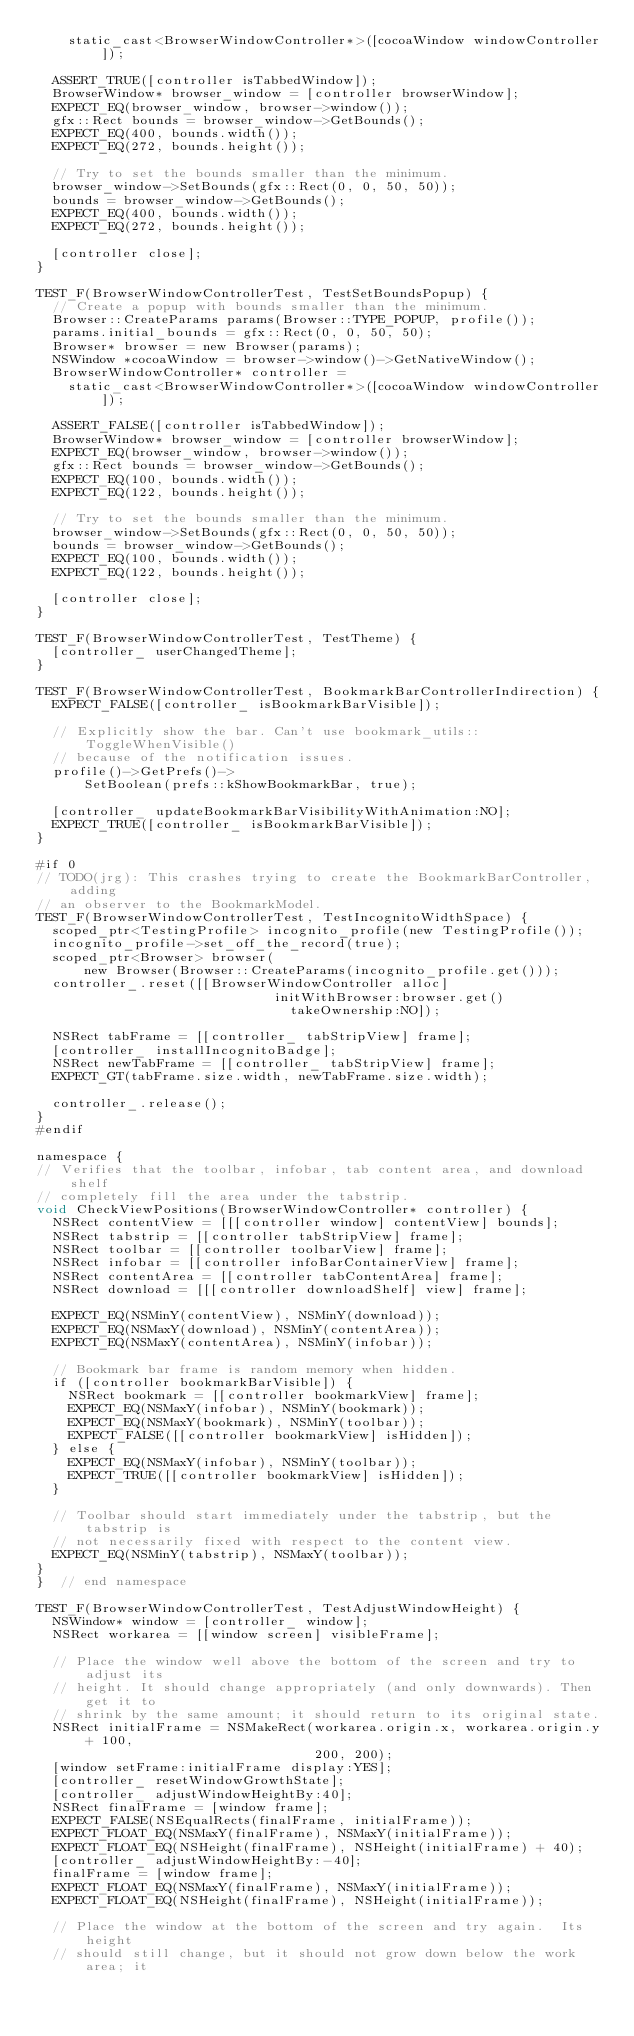Convert code to text. <code><loc_0><loc_0><loc_500><loc_500><_ObjectiveC_>    static_cast<BrowserWindowController*>([cocoaWindow windowController]);

  ASSERT_TRUE([controller isTabbedWindow]);
  BrowserWindow* browser_window = [controller browserWindow];
  EXPECT_EQ(browser_window, browser->window());
  gfx::Rect bounds = browser_window->GetBounds();
  EXPECT_EQ(400, bounds.width());
  EXPECT_EQ(272, bounds.height());

  // Try to set the bounds smaller than the minimum.
  browser_window->SetBounds(gfx::Rect(0, 0, 50, 50));
  bounds = browser_window->GetBounds();
  EXPECT_EQ(400, bounds.width());
  EXPECT_EQ(272, bounds.height());

  [controller close];
}

TEST_F(BrowserWindowControllerTest, TestSetBoundsPopup) {
  // Create a popup with bounds smaller than the minimum.
  Browser::CreateParams params(Browser::TYPE_POPUP, profile());
  params.initial_bounds = gfx::Rect(0, 0, 50, 50);
  Browser* browser = new Browser(params);
  NSWindow *cocoaWindow = browser->window()->GetNativeWindow();
  BrowserWindowController* controller =
    static_cast<BrowserWindowController*>([cocoaWindow windowController]);

  ASSERT_FALSE([controller isTabbedWindow]);
  BrowserWindow* browser_window = [controller browserWindow];
  EXPECT_EQ(browser_window, browser->window());
  gfx::Rect bounds = browser_window->GetBounds();
  EXPECT_EQ(100, bounds.width());
  EXPECT_EQ(122, bounds.height());

  // Try to set the bounds smaller than the minimum.
  browser_window->SetBounds(gfx::Rect(0, 0, 50, 50));
  bounds = browser_window->GetBounds();
  EXPECT_EQ(100, bounds.width());
  EXPECT_EQ(122, bounds.height());

  [controller close];
}

TEST_F(BrowserWindowControllerTest, TestTheme) {
  [controller_ userChangedTheme];
}

TEST_F(BrowserWindowControllerTest, BookmarkBarControllerIndirection) {
  EXPECT_FALSE([controller_ isBookmarkBarVisible]);

  // Explicitly show the bar. Can't use bookmark_utils::ToggleWhenVisible()
  // because of the notification issues.
  profile()->GetPrefs()->
      SetBoolean(prefs::kShowBookmarkBar, true);

  [controller_ updateBookmarkBarVisibilityWithAnimation:NO];
  EXPECT_TRUE([controller_ isBookmarkBarVisible]);
}

#if 0
// TODO(jrg): This crashes trying to create the BookmarkBarController, adding
// an observer to the BookmarkModel.
TEST_F(BrowserWindowControllerTest, TestIncognitoWidthSpace) {
  scoped_ptr<TestingProfile> incognito_profile(new TestingProfile());
  incognito_profile->set_off_the_record(true);
  scoped_ptr<Browser> browser(
      new Browser(Browser::CreateParams(incognito_profile.get()));
  controller_.reset([[BrowserWindowController alloc]
                              initWithBrowser:browser.get()
                                takeOwnership:NO]);

  NSRect tabFrame = [[controller_ tabStripView] frame];
  [controller_ installIncognitoBadge];
  NSRect newTabFrame = [[controller_ tabStripView] frame];
  EXPECT_GT(tabFrame.size.width, newTabFrame.size.width);

  controller_.release();
}
#endif

namespace {
// Verifies that the toolbar, infobar, tab content area, and download shelf
// completely fill the area under the tabstrip.
void CheckViewPositions(BrowserWindowController* controller) {
  NSRect contentView = [[[controller window] contentView] bounds];
  NSRect tabstrip = [[controller tabStripView] frame];
  NSRect toolbar = [[controller toolbarView] frame];
  NSRect infobar = [[controller infoBarContainerView] frame];
  NSRect contentArea = [[controller tabContentArea] frame];
  NSRect download = [[[controller downloadShelf] view] frame];

  EXPECT_EQ(NSMinY(contentView), NSMinY(download));
  EXPECT_EQ(NSMaxY(download), NSMinY(contentArea));
  EXPECT_EQ(NSMaxY(contentArea), NSMinY(infobar));

  // Bookmark bar frame is random memory when hidden.
  if ([controller bookmarkBarVisible]) {
    NSRect bookmark = [[controller bookmarkView] frame];
    EXPECT_EQ(NSMaxY(infobar), NSMinY(bookmark));
    EXPECT_EQ(NSMaxY(bookmark), NSMinY(toolbar));
    EXPECT_FALSE([[controller bookmarkView] isHidden]);
  } else {
    EXPECT_EQ(NSMaxY(infobar), NSMinY(toolbar));
    EXPECT_TRUE([[controller bookmarkView] isHidden]);
  }

  // Toolbar should start immediately under the tabstrip, but the tabstrip is
  // not necessarily fixed with respect to the content view.
  EXPECT_EQ(NSMinY(tabstrip), NSMaxY(toolbar));
}
}  // end namespace

TEST_F(BrowserWindowControllerTest, TestAdjustWindowHeight) {
  NSWindow* window = [controller_ window];
  NSRect workarea = [[window screen] visibleFrame];

  // Place the window well above the bottom of the screen and try to adjust its
  // height. It should change appropriately (and only downwards). Then get it to
  // shrink by the same amount; it should return to its original state.
  NSRect initialFrame = NSMakeRect(workarea.origin.x, workarea.origin.y + 100,
                                   200, 200);
  [window setFrame:initialFrame display:YES];
  [controller_ resetWindowGrowthState];
  [controller_ adjustWindowHeightBy:40];
  NSRect finalFrame = [window frame];
  EXPECT_FALSE(NSEqualRects(finalFrame, initialFrame));
  EXPECT_FLOAT_EQ(NSMaxY(finalFrame), NSMaxY(initialFrame));
  EXPECT_FLOAT_EQ(NSHeight(finalFrame), NSHeight(initialFrame) + 40);
  [controller_ adjustWindowHeightBy:-40];
  finalFrame = [window frame];
  EXPECT_FLOAT_EQ(NSMaxY(finalFrame), NSMaxY(initialFrame));
  EXPECT_FLOAT_EQ(NSHeight(finalFrame), NSHeight(initialFrame));

  // Place the window at the bottom of the screen and try again.  Its height
  // should still change, but it should not grow down below the work area; it</code> 